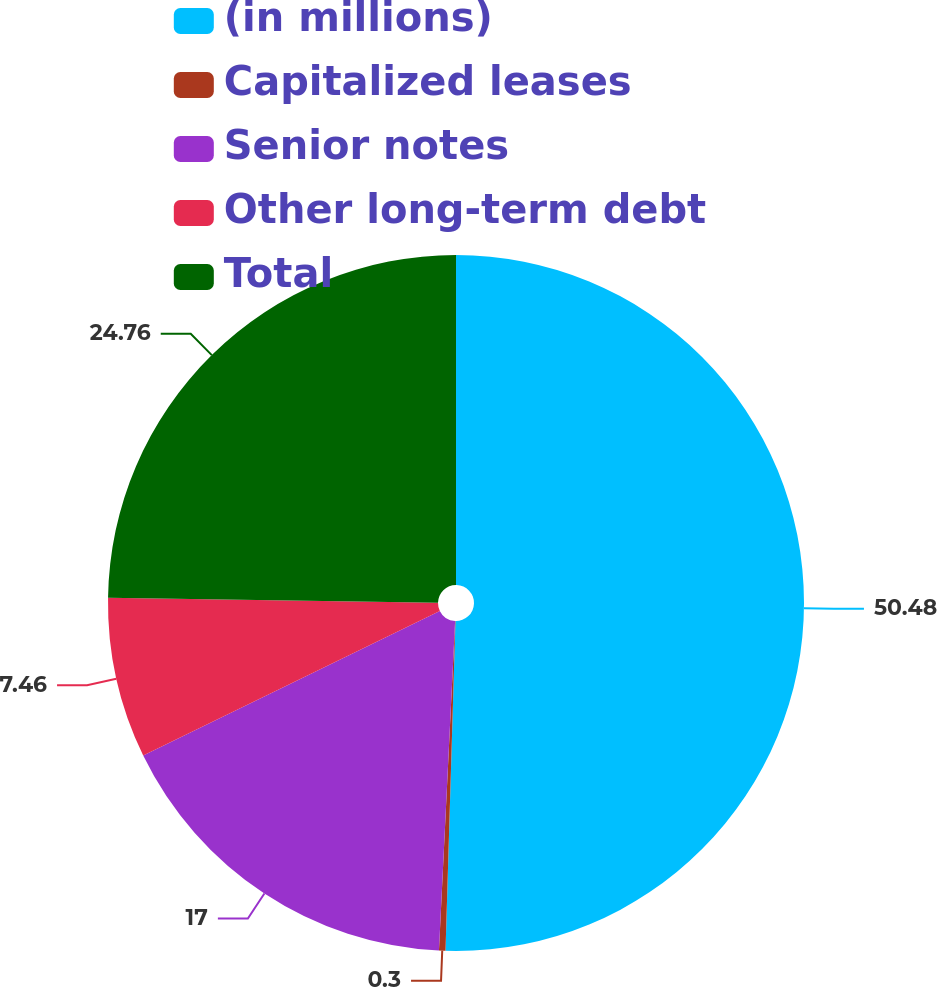<chart> <loc_0><loc_0><loc_500><loc_500><pie_chart><fcel>(in millions)<fcel>Capitalized leases<fcel>Senior notes<fcel>Other long-term debt<fcel>Total<nl><fcel>50.48%<fcel>0.3%<fcel>17.0%<fcel>7.46%<fcel>24.76%<nl></chart> 